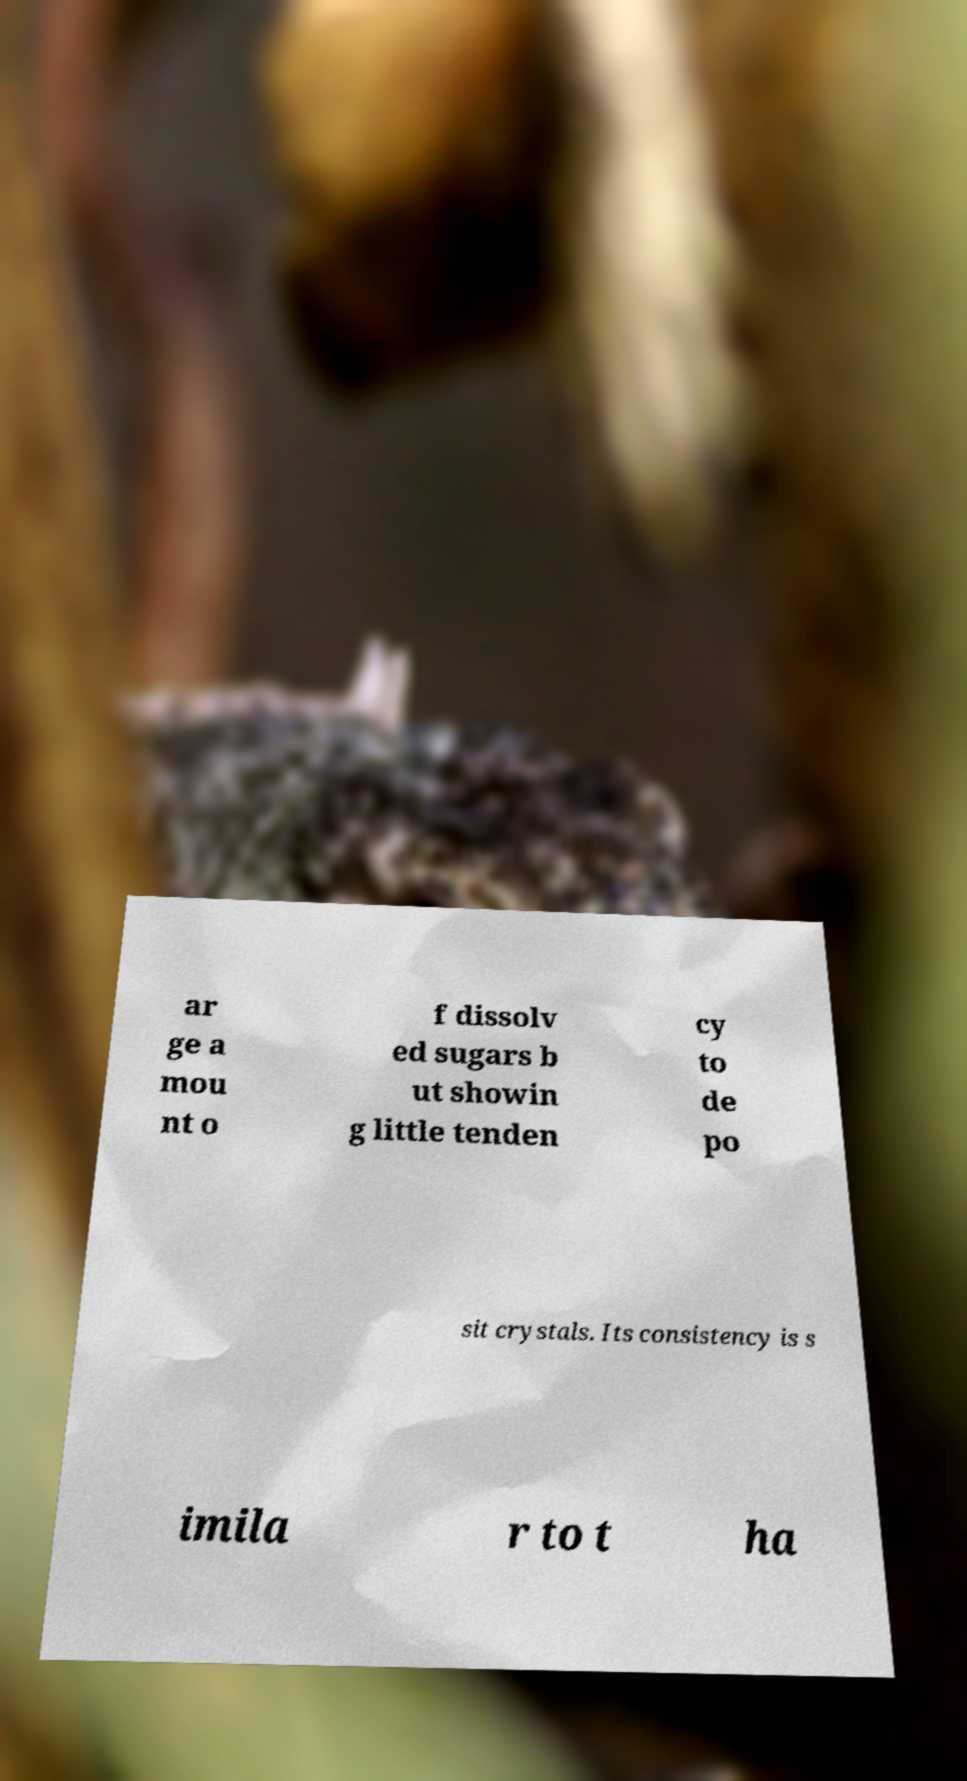There's text embedded in this image that I need extracted. Can you transcribe it verbatim? ar ge a mou nt o f dissolv ed sugars b ut showin g little tenden cy to de po sit crystals. Its consistency is s imila r to t ha 